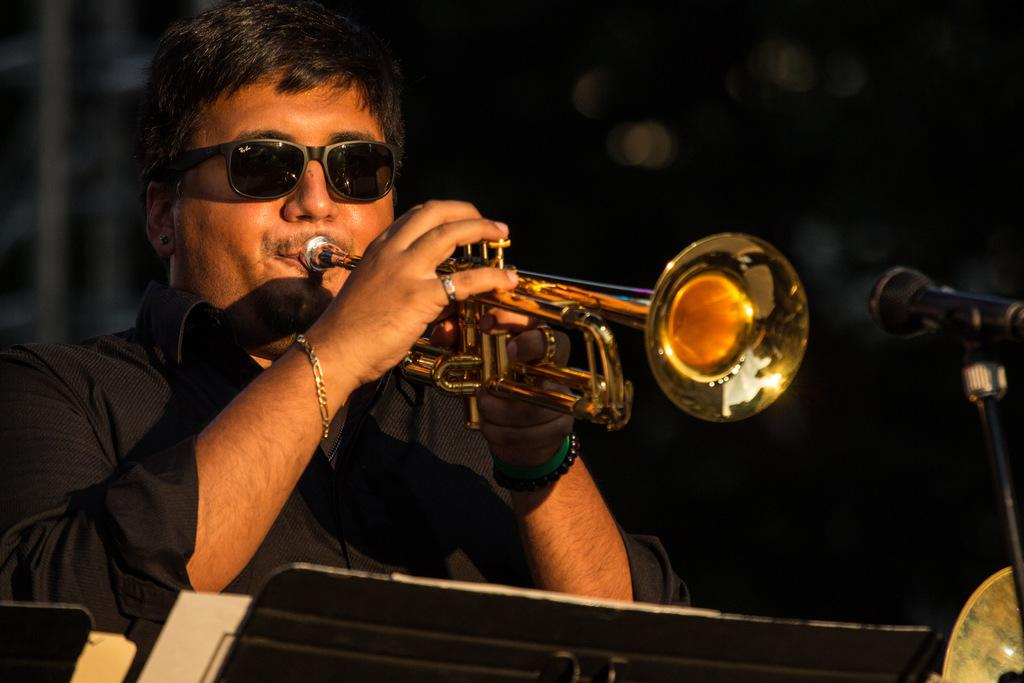What is the color of the background in the image? The background of the image is dark. What object can be seen in the image that is commonly used for amplifying sound? There is a microphone in the image. Can you describe the person in the image? The man in the image is wearing a black shirt and goggles. What is the man doing in the image? The man is playing a musical instrument. Are there any accessories visible in the image? Yes, there is a bracelet in the image. How many letters can be seen floating in the sea in the image? There is no sea or letters present in the image. What type of potato is being used as a musical instrument in the image? There is no potato being used as a musical instrument in the image. 